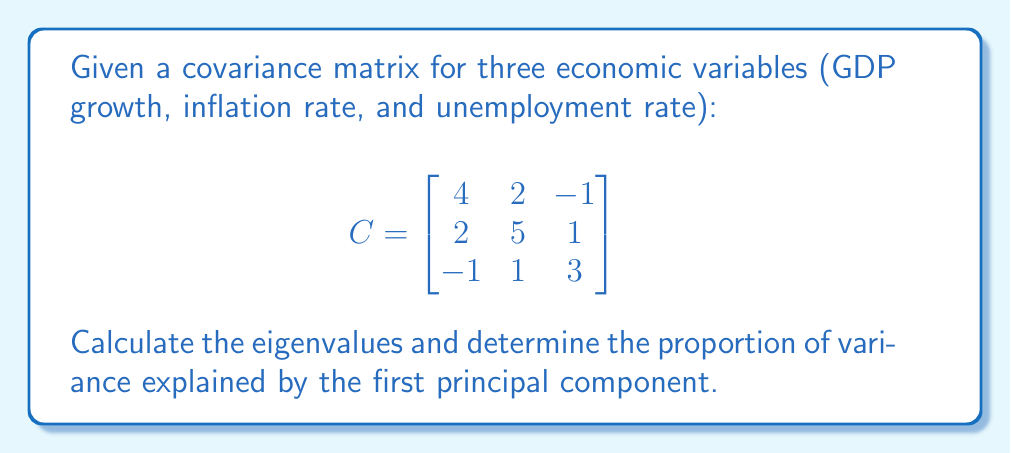Can you answer this question? 1) To find the eigenvalues, we solve the characteristic equation:
   $$\det(C - \lambda I) = 0$$

2) Expand the determinant:
   $$\begin{vmatrix}
   4-\lambda & 2 & -1 \\
   2 & 5-\lambda & 1 \\
   -1 & 1 & 3-\lambda
   \end{vmatrix} = 0$$

3) This yields the cubic equation:
   $$-\lambda^3 + 12\lambda^2 - 31\lambda + 20 = 0$$

4) Solving this equation (using a calculator or computer algebra system) gives the eigenvalues:
   $$\lambda_1 \approx 7.5359, \lambda_2 \approx 3.5138, \lambda_3 \approx 0.9503$$

5) The total variance is the sum of the eigenvalues:
   $$\text{Total Variance} = 7.5359 + 3.5138 + 0.9503 = 12$$

6) The proportion of variance explained by the first principal component is:
   $$\frac{\lambda_1}{\text{Total Variance}} = \frac{7.5359}{12} \approx 0.6280$$

7) Convert to percentage:
   $$0.6280 \times 100\% \approx 62.80\%$$
Answer: 62.80% 